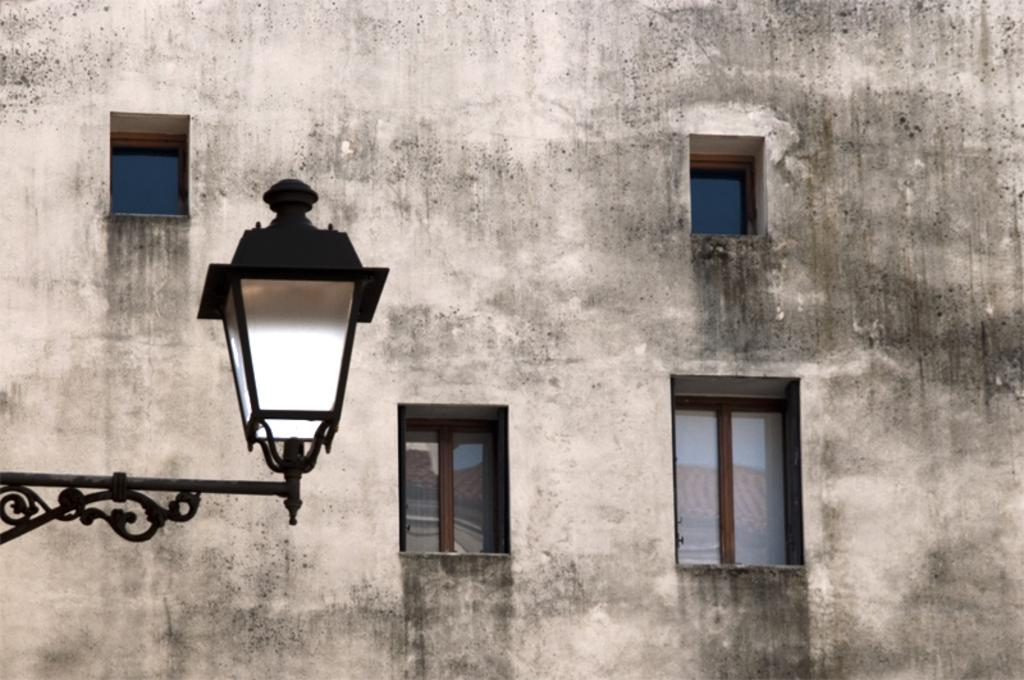What is located on the left side of the image? There is a light on a rod on the left side of the image. What can be seen in the background of the image? There is a wall and windows in the background of the image. Can you tell me how many matches are on the floor in the image? There are no matches present in the image. What type of garden can be seen through the windows in the image? There is no garden visible through the windows in the image; only the wall and windows are present. 